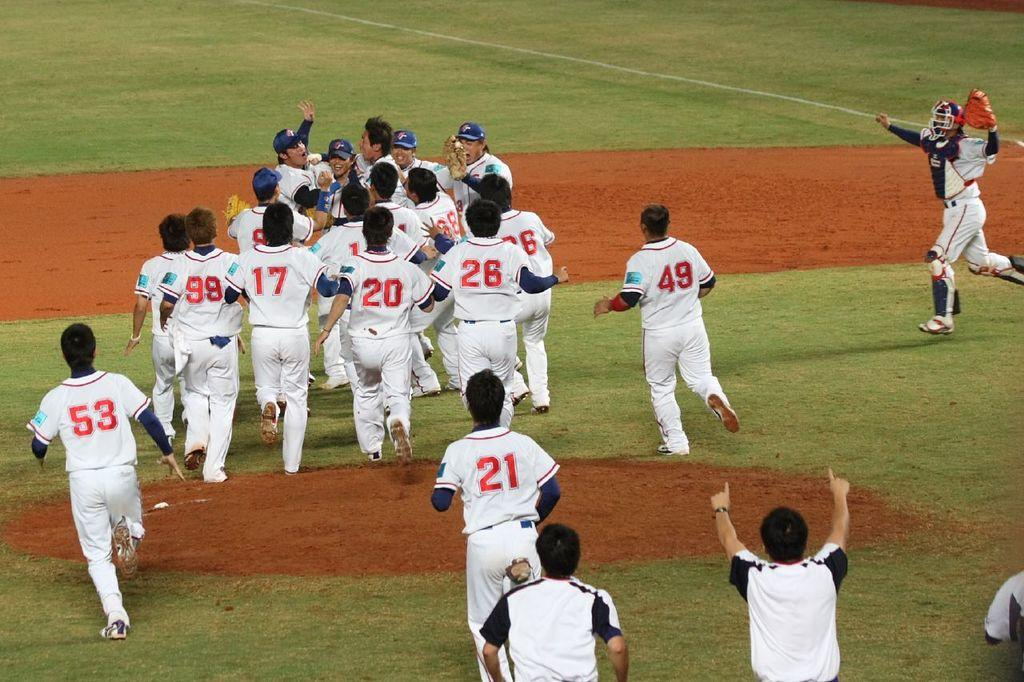Provide a one-sentence caption for the provided image. a few people that are celebrating on the field with the number 21 on their jersey. 